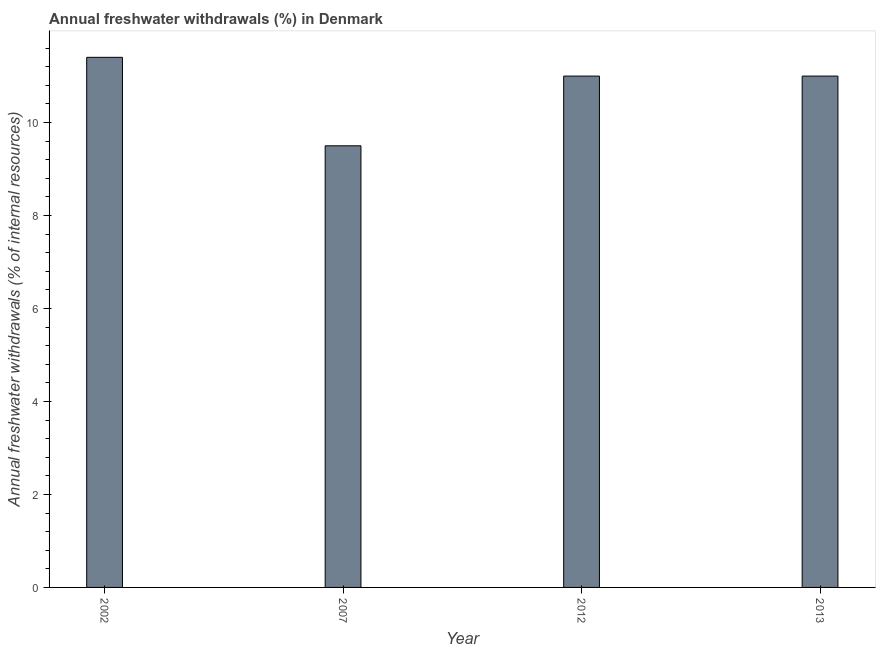What is the title of the graph?
Keep it short and to the point. Annual freshwater withdrawals (%) in Denmark. What is the label or title of the X-axis?
Offer a terse response. Year. What is the label or title of the Y-axis?
Your answer should be compact. Annual freshwater withdrawals (% of internal resources). What is the annual freshwater withdrawals in 2002?
Provide a succinct answer. 11.4. Across all years, what is the maximum annual freshwater withdrawals?
Make the answer very short. 11.4. Across all years, what is the minimum annual freshwater withdrawals?
Your response must be concise. 9.5. In which year was the annual freshwater withdrawals minimum?
Your answer should be very brief. 2007. What is the sum of the annual freshwater withdrawals?
Your response must be concise. 42.9. What is the difference between the annual freshwater withdrawals in 2002 and 2007?
Offer a very short reply. 1.9. What is the average annual freshwater withdrawals per year?
Keep it short and to the point. 10.73. In how many years, is the annual freshwater withdrawals greater than 2 %?
Offer a very short reply. 4. Do a majority of the years between 2002 and 2007 (inclusive) have annual freshwater withdrawals greater than 8.8 %?
Provide a short and direct response. Yes. What is the ratio of the annual freshwater withdrawals in 2007 to that in 2012?
Offer a terse response. 0.86. Is the annual freshwater withdrawals in 2002 less than that in 2012?
Offer a very short reply. No. What is the difference between the highest and the second highest annual freshwater withdrawals?
Keep it short and to the point. 0.4. Is the sum of the annual freshwater withdrawals in 2007 and 2013 greater than the maximum annual freshwater withdrawals across all years?
Give a very brief answer. Yes. What is the difference between the highest and the lowest annual freshwater withdrawals?
Make the answer very short. 1.9. What is the difference between two consecutive major ticks on the Y-axis?
Your response must be concise. 2. Are the values on the major ticks of Y-axis written in scientific E-notation?
Provide a succinct answer. No. What is the Annual freshwater withdrawals (% of internal resources) in 2002?
Your answer should be compact. 11.4. What is the difference between the Annual freshwater withdrawals (% of internal resources) in 2002 and 2007?
Ensure brevity in your answer.  1.9. What is the difference between the Annual freshwater withdrawals (% of internal resources) in 2002 and 2012?
Give a very brief answer. 0.4. What is the difference between the Annual freshwater withdrawals (% of internal resources) in 2002 and 2013?
Your response must be concise. 0.4. What is the difference between the Annual freshwater withdrawals (% of internal resources) in 2007 and 2012?
Provide a succinct answer. -1.5. What is the ratio of the Annual freshwater withdrawals (% of internal resources) in 2002 to that in 2007?
Offer a very short reply. 1.2. What is the ratio of the Annual freshwater withdrawals (% of internal resources) in 2002 to that in 2012?
Your answer should be compact. 1.04. What is the ratio of the Annual freshwater withdrawals (% of internal resources) in 2007 to that in 2012?
Offer a terse response. 0.86. What is the ratio of the Annual freshwater withdrawals (% of internal resources) in 2007 to that in 2013?
Provide a short and direct response. 0.86. What is the ratio of the Annual freshwater withdrawals (% of internal resources) in 2012 to that in 2013?
Offer a very short reply. 1. 